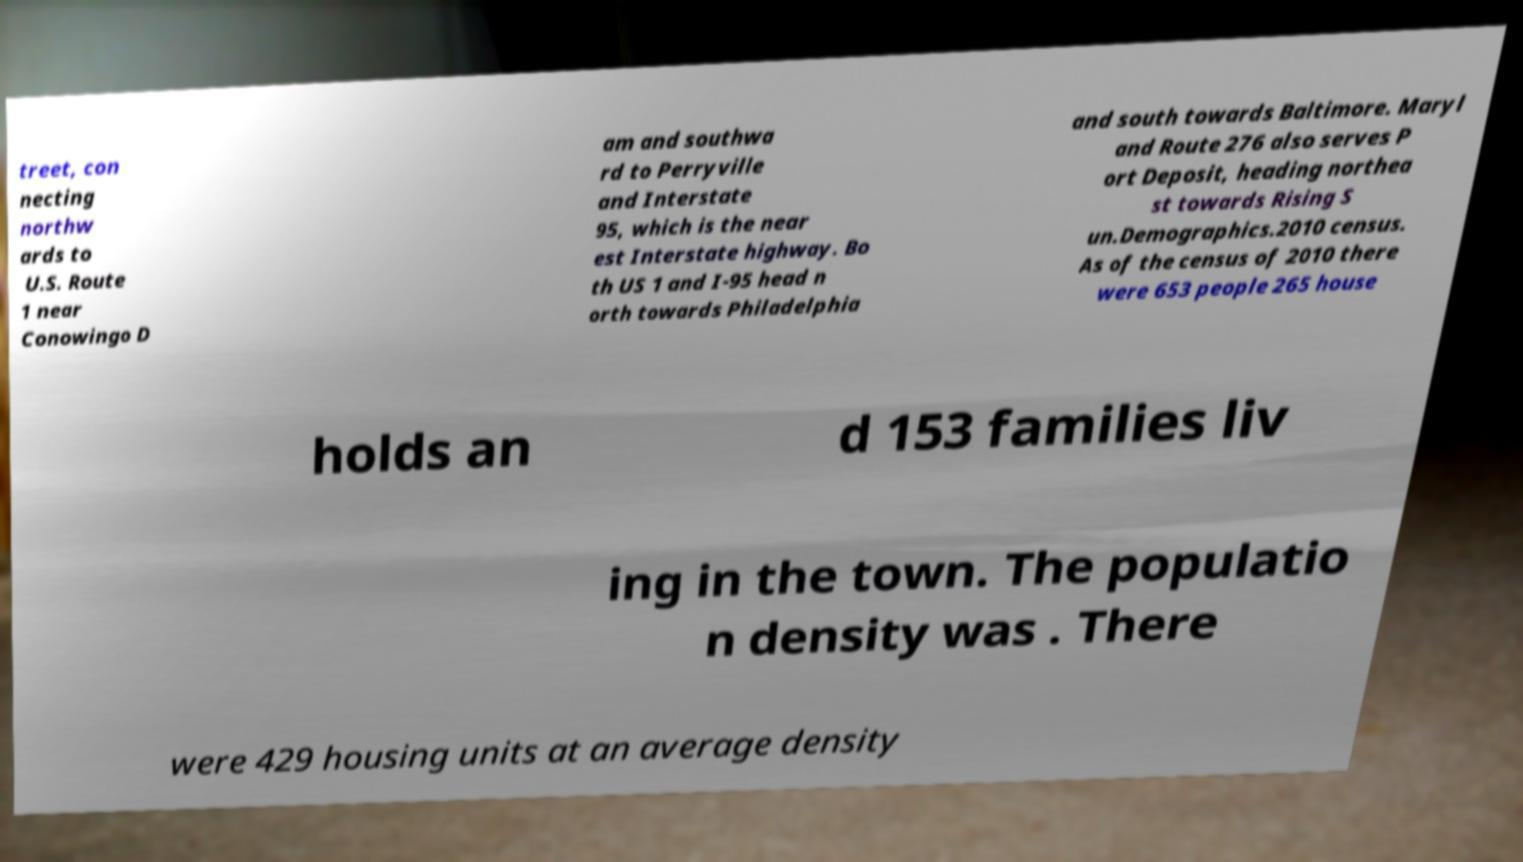Can you accurately transcribe the text from the provided image for me? treet, con necting northw ards to U.S. Route 1 near Conowingo D am and southwa rd to Perryville and Interstate 95, which is the near est Interstate highway. Bo th US 1 and I-95 head n orth towards Philadelphia and south towards Baltimore. Maryl and Route 276 also serves P ort Deposit, heading northea st towards Rising S un.Demographics.2010 census. As of the census of 2010 there were 653 people 265 house holds an d 153 families liv ing in the town. The populatio n density was . There were 429 housing units at an average density 